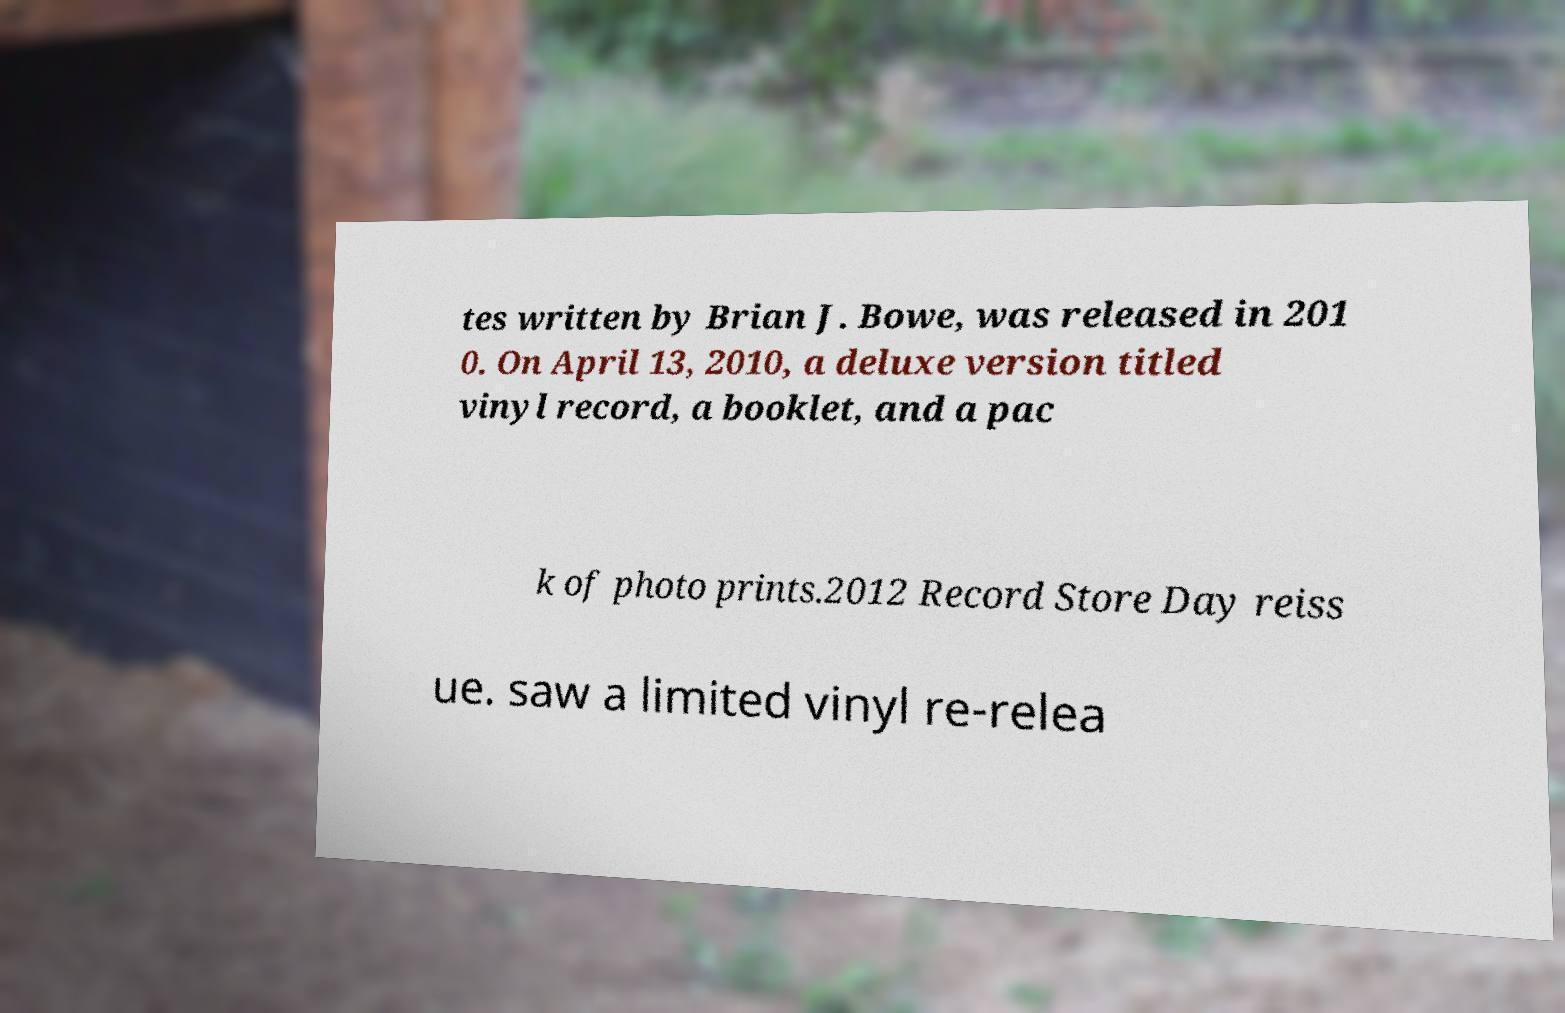Please identify and transcribe the text found in this image. tes written by Brian J. Bowe, was released in 201 0. On April 13, 2010, a deluxe version titled vinyl record, a booklet, and a pac k of photo prints.2012 Record Store Day reiss ue. saw a limited vinyl re-relea 